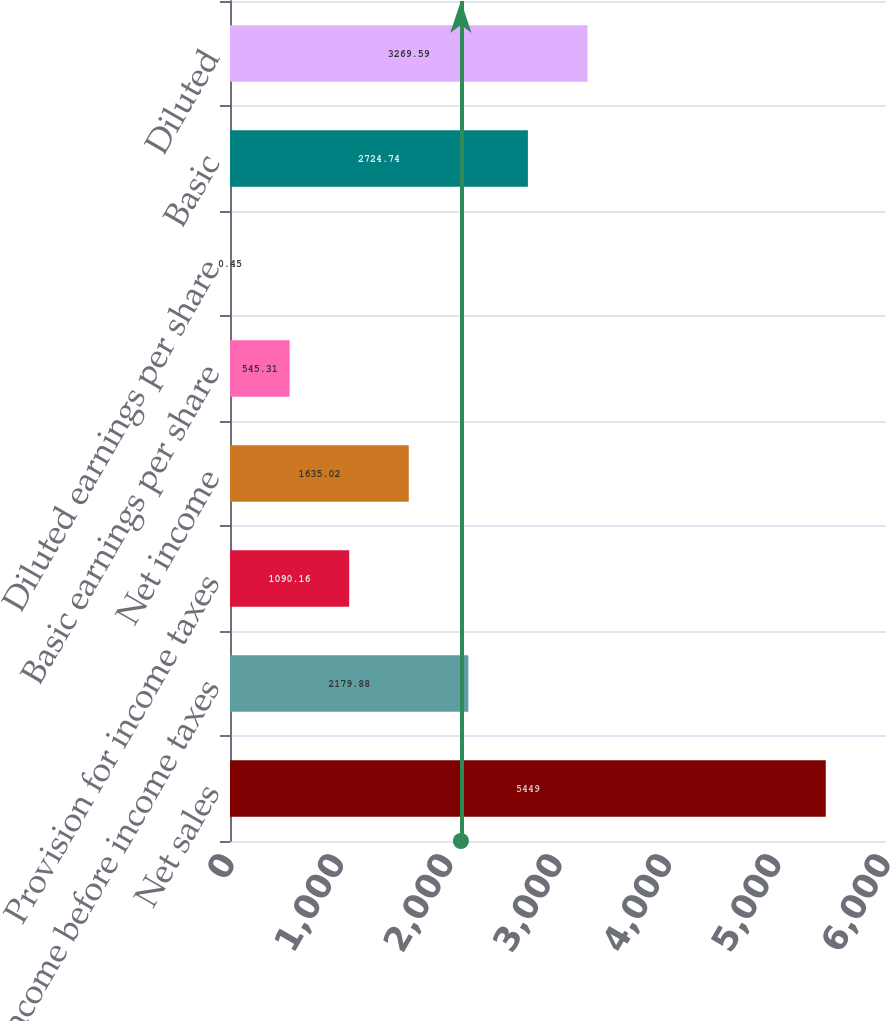Convert chart to OTSL. <chart><loc_0><loc_0><loc_500><loc_500><bar_chart><fcel>Net sales<fcel>Income before income taxes<fcel>Provision for income taxes<fcel>Net income<fcel>Basic earnings per share<fcel>Diluted earnings per share<fcel>Basic<fcel>Diluted<nl><fcel>5449<fcel>2179.88<fcel>1090.16<fcel>1635.02<fcel>545.31<fcel>0.45<fcel>2724.74<fcel>3269.59<nl></chart> 